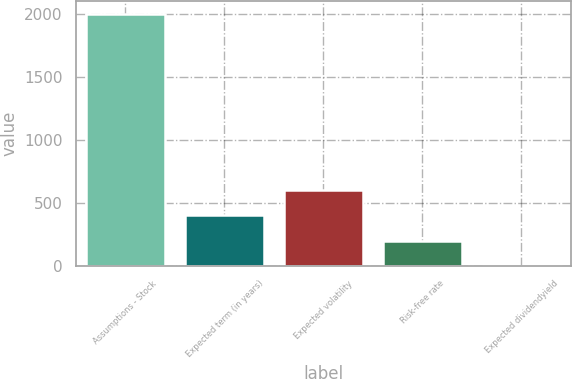<chart> <loc_0><loc_0><loc_500><loc_500><bar_chart><fcel>Assumptions - Stock<fcel>Expected term (in years)<fcel>Expected volatility<fcel>Risk-free rate<fcel>Expected dividendyield<nl><fcel>2005<fcel>401.32<fcel>601.78<fcel>200.86<fcel>0.4<nl></chart> 